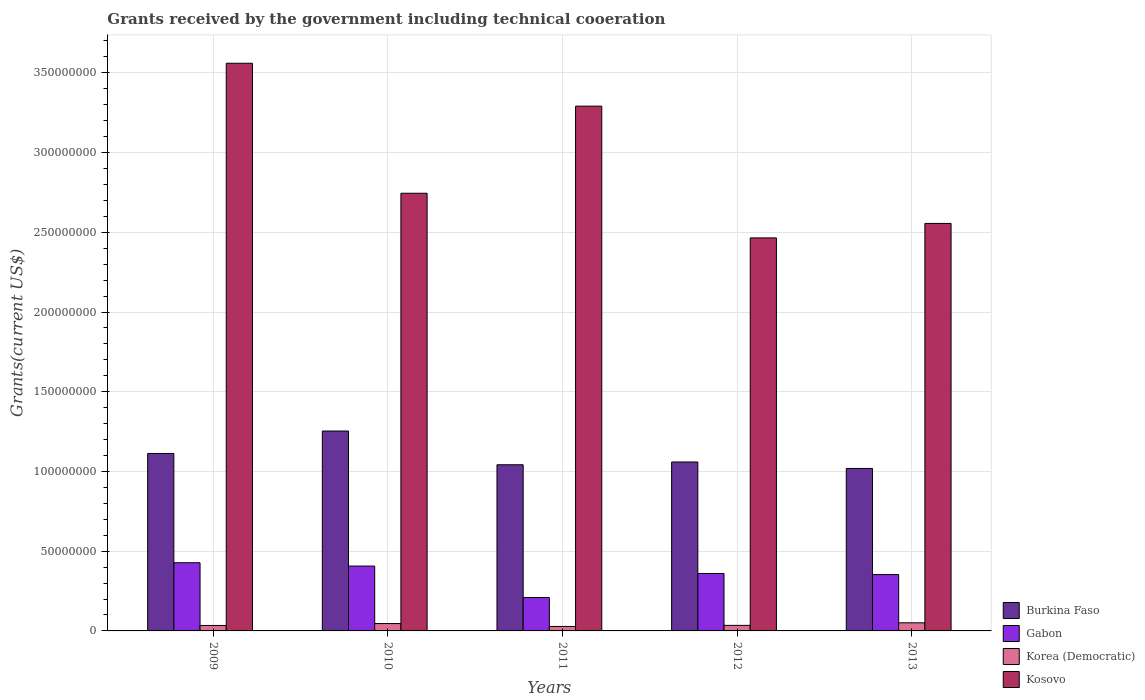How many groups of bars are there?
Provide a short and direct response. 5. How many bars are there on the 4th tick from the right?
Ensure brevity in your answer.  4. In how many cases, is the number of bars for a given year not equal to the number of legend labels?
Keep it short and to the point. 0. What is the total grants received by the government in Korea (Democratic) in 2010?
Your answer should be very brief. 4.62e+06. Across all years, what is the maximum total grants received by the government in Kosovo?
Offer a very short reply. 3.56e+08. Across all years, what is the minimum total grants received by the government in Korea (Democratic)?
Ensure brevity in your answer.  2.80e+06. In which year was the total grants received by the government in Korea (Democratic) maximum?
Offer a terse response. 2013. What is the total total grants received by the government in Kosovo in the graph?
Your answer should be compact. 1.46e+09. What is the difference between the total grants received by the government in Gabon in 2010 and that in 2011?
Offer a terse response. 1.97e+07. What is the difference between the total grants received by the government in Gabon in 2009 and the total grants received by the government in Kosovo in 2013?
Offer a very short reply. -2.13e+08. What is the average total grants received by the government in Kosovo per year?
Provide a short and direct response. 2.92e+08. In the year 2011, what is the difference between the total grants received by the government in Burkina Faso and total grants received by the government in Kosovo?
Offer a terse response. -2.25e+08. What is the ratio of the total grants received by the government in Kosovo in 2009 to that in 2011?
Ensure brevity in your answer.  1.08. Is the total grants received by the government in Kosovo in 2010 less than that in 2011?
Make the answer very short. Yes. Is the difference between the total grants received by the government in Burkina Faso in 2010 and 2012 greater than the difference between the total grants received by the government in Kosovo in 2010 and 2012?
Your answer should be very brief. No. What is the difference between the highest and the second highest total grants received by the government in Korea (Democratic)?
Offer a very short reply. 4.70e+05. What is the difference between the highest and the lowest total grants received by the government in Gabon?
Provide a short and direct response. 2.18e+07. Is the sum of the total grants received by the government in Kosovo in 2010 and 2012 greater than the maximum total grants received by the government in Burkina Faso across all years?
Provide a short and direct response. Yes. What does the 3rd bar from the left in 2010 represents?
Offer a terse response. Korea (Democratic). What does the 4th bar from the right in 2010 represents?
Provide a succinct answer. Burkina Faso. Are all the bars in the graph horizontal?
Offer a terse response. No. How many years are there in the graph?
Provide a succinct answer. 5. Are the values on the major ticks of Y-axis written in scientific E-notation?
Make the answer very short. No. Where does the legend appear in the graph?
Give a very brief answer. Bottom right. How many legend labels are there?
Offer a terse response. 4. How are the legend labels stacked?
Provide a succinct answer. Vertical. What is the title of the graph?
Provide a succinct answer. Grants received by the government including technical cooeration. What is the label or title of the X-axis?
Provide a short and direct response. Years. What is the label or title of the Y-axis?
Offer a very short reply. Grants(current US$). What is the Grants(current US$) of Burkina Faso in 2009?
Keep it short and to the point. 1.11e+08. What is the Grants(current US$) of Gabon in 2009?
Provide a short and direct response. 4.28e+07. What is the Grants(current US$) in Korea (Democratic) in 2009?
Ensure brevity in your answer.  3.42e+06. What is the Grants(current US$) in Kosovo in 2009?
Ensure brevity in your answer.  3.56e+08. What is the Grants(current US$) in Burkina Faso in 2010?
Offer a very short reply. 1.25e+08. What is the Grants(current US$) in Gabon in 2010?
Give a very brief answer. 4.07e+07. What is the Grants(current US$) in Korea (Democratic) in 2010?
Provide a succinct answer. 4.62e+06. What is the Grants(current US$) of Kosovo in 2010?
Keep it short and to the point. 2.74e+08. What is the Grants(current US$) of Burkina Faso in 2011?
Keep it short and to the point. 1.04e+08. What is the Grants(current US$) in Gabon in 2011?
Your answer should be compact. 2.10e+07. What is the Grants(current US$) of Korea (Democratic) in 2011?
Offer a very short reply. 2.80e+06. What is the Grants(current US$) in Kosovo in 2011?
Provide a short and direct response. 3.29e+08. What is the Grants(current US$) of Burkina Faso in 2012?
Provide a short and direct response. 1.06e+08. What is the Grants(current US$) in Gabon in 2012?
Your answer should be compact. 3.60e+07. What is the Grants(current US$) in Korea (Democratic) in 2012?
Offer a terse response. 3.48e+06. What is the Grants(current US$) in Kosovo in 2012?
Offer a terse response. 2.46e+08. What is the Grants(current US$) of Burkina Faso in 2013?
Offer a terse response. 1.02e+08. What is the Grants(current US$) in Gabon in 2013?
Your answer should be very brief. 3.53e+07. What is the Grants(current US$) in Korea (Democratic) in 2013?
Ensure brevity in your answer.  5.09e+06. What is the Grants(current US$) of Kosovo in 2013?
Provide a succinct answer. 2.56e+08. Across all years, what is the maximum Grants(current US$) in Burkina Faso?
Your response must be concise. 1.25e+08. Across all years, what is the maximum Grants(current US$) in Gabon?
Ensure brevity in your answer.  4.28e+07. Across all years, what is the maximum Grants(current US$) in Korea (Democratic)?
Offer a very short reply. 5.09e+06. Across all years, what is the maximum Grants(current US$) in Kosovo?
Your answer should be very brief. 3.56e+08. Across all years, what is the minimum Grants(current US$) in Burkina Faso?
Give a very brief answer. 1.02e+08. Across all years, what is the minimum Grants(current US$) of Gabon?
Your response must be concise. 2.10e+07. Across all years, what is the minimum Grants(current US$) in Korea (Democratic)?
Your answer should be very brief. 2.80e+06. Across all years, what is the minimum Grants(current US$) in Kosovo?
Make the answer very short. 2.46e+08. What is the total Grants(current US$) in Burkina Faso in the graph?
Provide a short and direct response. 5.49e+08. What is the total Grants(current US$) in Gabon in the graph?
Your answer should be very brief. 1.76e+08. What is the total Grants(current US$) of Korea (Democratic) in the graph?
Your answer should be very brief. 1.94e+07. What is the total Grants(current US$) in Kosovo in the graph?
Your answer should be very brief. 1.46e+09. What is the difference between the Grants(current US$) in Burkina Faso in 2009 and that in 2010?
Your answer should be compact. -1.41e+07. What is the difference between the Grants(current US$) of Gabon in 2009 and that in 2010?
Offer a terse response. 2.08e+06. What is the difference between the Grants(current US$) in Korea (Democratic) in 2009 and that in 2010?
Your answer should be compact. -1.20e+06. What is the difference between the Grants(current US$) of Kosovo in 2009 and that in 2010?
Make the answer very short. 8.15e+07. What is the difference between the Grants(current US$) of Burkina Faso in 2009 and that in 2011?
Your answer should be very brief. 7.07e+06. What is the difference between the Grants(current US$) of Gabon in 2009 and that in 2011?
Provide a succinct answer. 2.18e+07. What is the difference between the Grants(current US$) of Korea (Democratic) in 2009 and that in 2011?
Your answer should be very brief. 6.20e+05. What is the difference between the Grants(current US$) of Kosovo in 2009 and that in 2011?
Provide a short and direct response. 2.69e+07. What is the difference between the Grants(current US$) in Burkina Faso in 2009 and that in 2012?
Your answer should be very brief. 5.34e+06. What is the difference between the Grants(current US$) in Gabon in 2009 and that in 2012?
Provide a short and direct response. 6.74e+06. What is the difference between the Grants(current US$) in Korea (Democratic) in 2009 and that in 2012?
Your answer should be very brief. -6.00e+04. What is the difference between the Grants(current US$) in Kosovo in 2009 and that in 2012?
Give a very brief answer. 1.10e+08. What is the difference between the Grants(current US$) in Burkina Faso in 2009 and that in 2013?
Your answer should be very brief. 9.39e+06. What is the difference between the Grants(current US$) in Gabon in 2009 and that in 2013?
Give a very brief answer. 7.42e+06. What is the difference between the Grants(current US$) of Korea (Democratic) in 2009 and that in 2013?
Give a very brief answer. -1.67e+06. What is the difference between the Grants(current US$) of Kosovo in 2009 and that in 2013?
Your response must be concise. 1.00e+08. What is the difference between the Grants(current US$) of Burkina Faso in 2010 and that in 2011?
Keep it short and to the point. 2.12e+07. What is the difference between the Grants(current US$) in Gabon in 2010 and that in 2011?
Your answer should be very brief. 1.97e+07. What is the difference between the Grants(current US$) in Korea (Democratic) in 2010 and that in 2011?
Give a very brief answer. 1.82e+06. What is the difference between the Grants(current US$) in Kosovo in 2010 and that in 2011?
Give a very brief answer. -5.46e+07. What is the difference between the Grants(current US$) in Burkina Faso in 2010 and that in 2012?
Your answer should be compact. 1.94e+07. What is the difference between the Grants(current US$) of Gabon in 2010 and that in 2012?
Keep it short and to the point. 4.66e+06. What is the difference between the Grants(current US$) in Korea (Democratic) in 2010 and that in 2012?
Offer a very short reply. 1.14e+06. What is the difference between the Grants(current US$) in Kosovo in 2010 and that in 2012?
Your response must be concise. 2.80e+07. What is the difference between the Grants(current US$) in Burkina Faso in 2010 and that in 2013?
Provide a succinct answer. 2.35e+07. What is the difference between the Grants(current US$) in Gabon in 2010 and that in 2013?
Offer a very short reply. 5.34e+06. What is the difference between the Grants(current US$) of Korea (Democratic) in 2010 and that in 2013?
Offer a terse response. -4.70e+05. What is the difference between the Grants(current US$) in Kosovo in 2010 and that in 2013?
Keep it short and to the point. 1.89e+07. What is the difference between the Grants(current US$) of Burkina Faso in 2011 and that in 2012?
Offer a terse response. -1.73e+06. What is the difference between the Grants(current US$) in Gabon in 2011 and that in 2012?
Keep it short and to the point. -1.51e+07. What is the difference between the Grants(current US$) of Korea (Democratic) in 2011 and that in 2012?
Ensure brevity in your answer.  -6.80e+05. What is the difference between the Grants(current US$) of Kosovo in 2011 and that in 2012?
Offer a terse response. 8.26e+07. What is the difference between the Grants(current US$) in Burkina Faso in 2011 and that in 2013?
Ensure brevity in your answer.  2.32e+06. What is the difference between the Grants(current US$) in Gabon in 2011 and that in 2013?
Your answer should be compact. -1.44e+07. What is the difference between the Grants(current US$) of Korea (Democratic) in 2011 and that in 2013?
Your answer should be very brief. -2.29e+06. What is the difference between the Grants(current US$) in Kosovo in 2011 and that in 2013?
Give a very brief answer. 7.36e+07. What is the difference between the Grants(current US$) in Burkina Faso in 2012 and that in 2013?
Your response must be concise. 4.05e+06. What is the difference between the Grants(current US$) in Gabon in 2012 and that in 2013?
Keep it short and to the point. 6.80e+05. What is the difference between the Grants(current US$) of Korea (Democratic) in 2012 and that in 2013?
Make the answer very short. -1.61e+06. What is the difference between the Grants(current US$) in Kosovo in 2012 and that in 2013?
Give a very brief answer. -9.07e+06. What is the difference between the Grants(current US$) of Burkina Faso in 2009 and the Grants(current US$) of Gabon in 2010?
Keep it short and to the point. 7.06e+07. What is the difference between the Grants(current US$) in Burkina Faso in 2009 and the Grants(current US$) in Korea (Democratic) in 2010?
Offer a terse response. 1.07e+08. What is the difference between the Grants(current US$) in Burkina Faso in 2009 and the Grants(current US$) in Kosovo in 2010?
Give a very brief answer. -1.63e+08. What is the difference between the Grants(current US$) in Gabon in 2009 and the Grants(current US$) in Korea (Democratic) in 2010?
Provide a short and direct response. 3.81e+07. What is the difference between the Grants(current US$) of Gabon in 2009 and the Grants(current US$) of Kosovo in 2010?
Your answer should be compact. -2.32e+08. What is the difference between the Grants(current US$) in Korea (Democratic) in 2009 and the Grants(current US$) in Kosovo in 2010?
Provide a short and direct response. -2.71e+08. What is the difference between the Grants(current US$) in Burkina Faso in 2009 and the Grants(current US$) in Gabon in 2011?
Keep it short and to the point. 9.03e+07. What is the difference between the Grants(current US$) of Burkina Faso in 2009 and the Grants(current US$) of Korea (Democratic) in 2011?
Ensure brevity in your answer.  1.08e+08. What is the difference between the Grants(current US$) of Burkina Faso in 2009 and the Grants(current US$) of Kosovo in 2011?
Your answer should be very brief. -2.18e+08. What is the difference between the Grants(current US$) in Gabon in 2009 and the Grants(current US$) in Korea (Democratic) in 2011?
Provide a short and direct response. 4.00e+07. What is the difference between the Grants(current US$) of Gabon in 2009 and the Grants(current US$) of Kosovo in 2011?
Keep it short and to the point. -2.86e+08. What is the difference between the Grants(current US$) of Korea (Democratic) in 2009 and the Grants(current US$) of Kosovo in 2011?
Provide a short and direct response. -3.26e+08. What is the difference between the Grants(current US$) in Burkina Faso in 2009 and the Grants(current US$) in Gabon in 2012?
Provide a short and direct response. 7.53e+07. What is the difference between the Grants(current US$) of Burkina Faso in 2009 and the Grants(current US$) of Korea (Democratic) in 2012?
Your response must be concise. 1.08e+08. What is the difference between the Grants(current US$) in Burkina Faso in 2009 and the Grants(current US$) in Kosovo in 2012?
Give a very brief answer. -1.35e+08. What is the difference between the Grants(current US$) in Gabon in 2009 and the Grants(current US$) in Korea (Democratic) in 2012?
Your answer should be very brief. 3.93e+07. What is the difference between the Grants(current US$) in Gabon in 2009 and the Grants(current US$) in Kosovo in 2012?
Your response must be concise. -2.04e+08. What is the difference between the Grants(current US$) of Korea (Democratic) in 2009 and the Grants(current US$) of Kosovo in 2012?
Provide a short and direct response. -2.43e+08. What is the difference between the Grants(current US$) of Burkina Faso in 2009 and the Grants(current US$) of Gabon in 2013?
Ensure brevity in your answer.  7.60e+07. What is the difference between the Grants(current US$) in Burkina Faso in 2009 and the Grants(current US$) in Korea (Democratic) in 2013?
Your answer should be very brief. 1.06e+08. What is the difference between the Grants(current US$) in Burkina Faso in 2009 and the Grants(current US$) in Kosovo in 2013?
Your response must be concise. -1.44e+08. What is the difference between the Grants(current US$) in Gabon in 2009 and the Grants(current US$) in Korea (Democratic) in 2013?
Give a very brief answer. 3.77e+07. What is the difference between the Grants(current US$) in Gabon in 2009 and the Grants(current US$) in Kosovo in 2013?
Your response must be concise. -2.13e+08. What is the difference between the Grants(current US$) of Korea (Democratic) in 2009 and the Grants(current US$) of Kosovo in 2013?
Make the answer very short. -2.52e+08. What is the difference between the Grants(current US$) of Burkina Faso in 2010 and the Grants(current US$) of Gabon in 2011?
Your answer should be compact. 1.04e+08. What is the difference between the Grants(current US$) of Burkina Faso in 2010 and the Grants(current US$) of Korea (Democratic) in 2011?
Make the answer very short. 1.23e+08. What is the difference between the Grants(current US$) in Burkina Faso in 2010 and the Grants(current US$) in Kosovo in 2011?
Make the answer very short. -2.04e+08. What is the difference between the Grants(current US$) of Gabon in 2010 and the Grants(current US$) of Korea (Democratic) in 2011?
Ensure brevity in your answer.  3.79e+07. What is the difference between the Grants(current US$) in Gabon in 2010 and the Grants(current US$) in Kosovo in 2011?
Your answer should be compact. -2.88e+08. What is the difference between the Grants(current US$) in Korea (Democratic) in 2010 and the Grants(current US$) in Kosovo in 2011?
Provide a short and direct response. -3.25e+08. What is the difference between the Grants(current US$) in Burkina Faso in 2010 and the Grants(current US$) in Gabon in 2012?
Provide a short and direct response. 8.94e+07. What is the difference between the Grants(current US$) of Burkina Faso in 2010 and the Grants(current US$) of Korea (Democratic) in 2012?
Offer a terse response. 1.22e+08. What is the difference between the Grants(current US$) of Burkina Faso in 2010 and the Grants(current US$) of Kosovo in 2012?
Provide a succinct answer. -1.21e+08. What is the difference between the Grants(current US$) of Gabon in 2010 and the Grants(current US$) of Korea (Democratic) in 2012?
Give a very brief answer. 3.72e+07. What is the difference between the Grants(current US$) of Gabon in 2010 and the Grants(current US$) of Kosovo in 2012?
Your answer should be compact. -2.06e+08. What is the difference between the Grants(current US$) in Korea (Democratic) in 2010 and the Grants(current US$) in Kosovo in 2012?
Give a very brief answer. -2.42e+08. What is the difference between the Grants(current US$) in Burkina Faso in 2010 and the Grants(current US$) in Gabon in 2013?
Ensure brevity in your answer.  9.00e+07. What is the difference between the Grants(current US$) of Burkina Faso in 2010 and the Grants(current US$) of Korea (Democratic) in 2013?
Provide a short and direct response. 1.20e+08. What is the difference between the Grants(current US$) of Burkina Faso in 2010 and the Grants(current US$) of Kosovo in 2013?
Ensure brevity in your answer.  -1.30e+08. What is the difference between the Grants(current US$) in Gabon in 2010 and the Grants(current US$) in Korea (Democratic) in 2013?
Your answer should be compact. 3.56e+07. What is the difference between the Grants(current US$) of Gabon in 2010 and the Grants(current US$) of Kosovo in 2013?
Keep it short and to the point. -2.15e+08. What is the difference between the Grants(current US$) in Korea (Democratic) in 2010 and the Grants(current US$) in Kosovo in 2013?
Offer a very short reply. -2.51e+08. What is the difference between the Grants(current US$) of Burkina Faso in 2011 and the Grants(current US$) of Gabon in 2012?
Provide a short and direct response. 6.82e+07. What is the difference between the Grants(current US$) in Burkina Faso in 2011 and the Grants(current US$) in Korea (Democratic) in 2012?
Your answer should be compact. 1.01e+08. What is the difference between the Grants(current US$) of Burkina Faso in 2011 and the Grants(current US$) of Kosovo in 2012?
Offer a very short reply. -1.42e+08. What is the difference between the Grants(current US$) in Gabon in 2011 and the Grants(current US$) in Korea (Democratic) in 2012?
Make the answer very short. 1.75e+07. What is the difference between the Grants(current US$) of Gabon in 2011 and the Grants(current US$) of Kosovo in 2012?
Keep it short and to the point. -2.26e+08. What is the difference between the Grants(current US$) of Korea (Democratic) in 2011 and the Grants(current US$) of Kosovo in 2012?
Offer a very short reply. -2.44e+08. What is the difference between the Grants(current US$) in Burkina Faso in 2011 and the Grants(current US$) in Gabon in 2013?
Give a very brief answer. 6.89e+07. What is the difference between the Grants(current US$) in Burkina Faso in 2011 and the Grants(current US$) in Korea (Democratic) in 2013?
Provide a succinct answer. 9.91e+07. What is the difference between the Grants(current US$) in Burkina Faso in 2011 and the Grants(current US$) in Kosovo in 2013?
Make the answer very short. -1.51e+08. What is the difference between the Grants(current US$) of Gabon in 2011 and the Grants(current US$) of Korea (Democratic) in 2013?
Your answer should be very brief. 1.59e+07. What is the difference between the Grants(current US$) of Gabon in 2011 and the Grants(current US$) of Kosovo in 2013?
Your response must be concise. -2.35e+08. What is the difference between the Grants(current US$) in Korea (Democratic) in 2011 and the Grants(current US$) in Kosovo in 2013?
Provide a succinct answer. -2.53e+08. What is the difference between the Grants(current US$) in Burkina Faso in 2012 and the Grants(current US$) in Gabon in 2013?
Give a very brief answer. 7.06e+07. What is the difference between the Grants(current US$) in Burkina Faso in 2012 and the Grants(current US$) in Korea (Democratic) in 2013?
Provide a short and direct response. 1.01e+08. What is the difference between the Grants(current US$) of Burkina Faso in 2012 and the Grants(current US$) of Kosovo in 2013?
Offer a terse response. -1.50e+08. What is the difference between the Grants(current US$) in Gabon in 2012 and the Grants(current US$) in Korea (Democratic) in 2013?
Ensure brevity in your answer.  3.09e+07. What is the difference between the Grants(current US$) of Gabon in 2012 and the Grants(current US$) of Kosovo in 2013?
Your response must be concise. -2.20e+08. What is the difference between the Grants(current US$) of Korea (Democratic) in 2012 and the Grants(current US$) of Kosovo in 2013?
Make the answer very short. -2.52e+08. What is the average Grants(current US$) in Burkina Faso per year?
Your answer should be compact. 1.10e+08. What is the average Grants(current US$) in Gabon per year?
Provide a short and direct response. 3.52e+07. What is the average Grants(current US$) in Korea (Democratic) per year?
Provide a succinct answer. 3.88e+06. What is the average Grants(current US$) of Kosovo per year?
Your answer should be compact. 2.92e+08. In the year 2009, what is the difference between the Grants(current US$) of Burkina Faso and Grants(current US$) of Gabon?
Provide a short and direct response. 6.85e+07. In the year 2009, what is the difference between the Grants(current US$) of Burkina Faso and Grants(current US$) of Korea (Democratic)?
Provide a succinct answer. 1.08e+08. In the year 2009, what is the difference between the Grants(current US$) of Burkina Faso and Grants(current US$) of Kosovo?
Your response must be concise. -2.45e+08. In the year 2009, what is the difference between the Grants(current US$) in Gabon and Grants(current US$) in Korea (Democratic)?
Keep it short and to the point. 3.93e+07. In the year 2009, what is the difference between the Grants(current US$) in Gabon and Grants(current US$) in Kosovo?
Make the answer very short. -3.13e+08. In the year 2009, what is the difference between the Grants(current US$) of Korea (Democratic) and Grants(current US$) of Kosovo?
Keep it short and to the point. -3.53e+08. In the year 2010, what is the difference between the Grants(current US$) of Burkina Faso and Grants(current US$) of Gabon?
Your answer should be very brief. 8.47e+07. In the year 2010, what is the difference between the Grants(current US$) of Burkina Faso and Grants(current US$) of Korea (Democratic)?
Provide a short and direct response. 1.21e+08. In the year 2010, what is the difference between the Grants(current US$) of Burkina Faso and Grants(current US$) of Kosovo?
Make the answer very short. -1.49e+08. In the year 2010, what is the difference between the Grants(current US$) of Gabon and Grants(current US$) of Korea (Democratic)?
Keep it short and to the point. 3.61e+07. In the year 2010, what is the difference between the Grants(current US$) in Gabon and Grants(current US$) in Kosovo?
Give a very brief answer. -2.34e+08. In the year 2010, what is the difference between the Grants(current US$) in Korea (Democratic) and Grants(current US$) in Kosovo?
Your response must be concise. -2.70e+08. In the year 2011, what is the difference between the Grants(current US$) in Burkina Faso and Grants(current US$) in Gabon?
Keep it short and to the point. 8.33e+07. In the year 2011, what is the difference between the Grants(current US$) in Burkina Faso and Grants(current US$) in Korea (Democratic)?
Give a very brief answer. 1.01e+08. In the year 2011, what is the difference between the Grants(current US$) of Burkina Faso and Grants(current US$) of Kosovo?
Provide a short and direct response. -2.25e+08. In the year 2011, what is the difference between the Grants(current US$) of Gabon and Grants(current US$) of Korea (Democratic)?
Keep it short and to the point. 1.82e+07. In the year 2011, what is the difference between the Grants(current US$) of Gabon and Grants(current US$) of Kosovo?
Your answer should be compact. -3.08e+08. In the year 2011, what is the difference between the Grants(current US$) in Korea (Democratic) and Grants(current US$) in Kosovo?
Provide a short and direct response. -3.26e+08. In the year 2012, what is the difference between the Grants(current US$) in Burkina Faso and Grants(current US$) in Gabon?
Your answer should be compact. 6.99e+07. In the year 2012, what is the difference between the Grants(current US$) of Burkina Faso and Grants(current US$) of Korea (Democratic)?
Offer a very short reply. 1.02e+08. In the year 2012, what is the difference between the Grants(current US$) in Burkina Faso and Grants(current US$) in Kosovo?
Your answer should be very brief. -1.41e+08. In the year 2012, what is the difference between the Grants(current US$) in Gabon and Grants(current US$) in Korea (Democratic)?
Make the answer very short. 3.25e+07. In the year 2012, what is the difference between the Grants(current US$) of Gabon and Grants(current US$) of Kosovo?
Provide a short and direct response. -2.10e+08. In the year 2012, what is the difference between the Grants(current US$) of Korea (Democratic) and Grants(current US$) of Kosovo?
Ensure brevity in your answer.  -2.43e+08. In the year 2013, what is the difference between the Grants(current US$) of Burkina Faso and Grants(current US$) of Gabon?
Provide a short and direct response. 6.66e+07. In the year 2013, what is the difference between the Grants(current US$) of Burkina Faso and Grants(current US$) of Korea (Democratic)?
Give a very brief answer. 9.68e+07. In the year 2013, what is the difference between the Grants(current US$) of Burkina Faso and Grants(current US$) of Kosovo?
Offer a very short reply. -1.54e+08. In the year 2013, what is the difference between the Grants(current US$) in Gabon and Grants(current US$) in Korea (Democratic)?
Make the answer very short. 3.02e+07. In the year 2013, what is the difference between the Grants(current US$) in Gabon and Grants(current US$) in Kosovo?
Keep it short and to the point. -2.20e+08. In the year 2013, what is the difference between the Grants(current US$) in Korea (Democratic) and Grants(current US$) in Kosovo?
Your answer should be very brief. -2.50e+08. What is the ratio of the Grants(current US$) of Burkina Faso in 2009 to that in 2010?
Give a very brief answer. 0.89. What is the ratio of the Grants(current US$) of Gabon in 2009 to that in 2010?
Provide a succinct answer. 1.05. What is the ratio of the Grants(current US$) in Korea (Democratic) in 2009 to that in 2010?
Offer a very short reply. 0.74. What is the ratio of the Grants(current US$) of Kosovo in 2009 to that in 2010?
Your answer should be very brief. 1.3. What is the ratio of the Grants(current US$) in Burkina Faso in 2009 to that in 2011?
Make the answer very short. 1.07. What is the ratio of the Grants(current US$) in Gabon in 2009 to that in 2011?
Provide a succinct answer. 2.04. What is the ratio of the Grants(current US$) of Korea (Democratic) in 2009 to that in 2011?
Provide a short and direct response. 1.22. What is the ratio of the Grants(current US$) in Kosovo in 2009 to that in 2011?
Keep it short and to the point. 1.08. What is the ratio of the Grants(current US$) of Burkina Faso in 2009 to that in 2012?
Your answer should be very brief. 1.05. What is the ratio of the Grants(current US$) of Gabon in 2009 to that in 2012?
Your answer should be compact. 1.19. What is the ratio of the Grants(current US$) in Korea (Democratic) in 2009 to that in 2012?
Provide a succinct answer. 0.98. What is the ratio of the Grants(current US$) of Kosovo in 2009 to that in 2012?
Keep it short and to the point. 1.44. What is the ratio of the Grants(current US$) of Burkina Faso in 2009 to that in 2013?
Give a very brief answer. 1.09. What is the ratio of the Grants(current US$) of Gabon in 2009 to that in 2013?
Offer a terse response. 1.21. What is the ratio of the Grants(current US$) of Korea (Democratic) in 2009 to that in 2013?
Give a very brief answer. 0.67. What is the ratio of the Grants(current US$) in Kosovo in 2009 to that in 2013?
Keep it short and to the point. 1.39. What is the ratio of the Grants(current US$) of Burkina Faso in 2010 to that in 2011?
Your answer should be compact. 1.2. What is the ratio of the Grants(current US$) in Gabon in 2010 to that in 2011?
Offer a terse response. 1.94. What is the ratio of the Grants(current US$) in Korea (Democratic) in 2010 to that in 2011?
Provide a short and direct response. 1.65. What is the ratio of the Grants(current US$) in Kosovo in 2010 to that in 2011?
Provide a succinct answer. 0.83. What is the ratio of the Grants(current US$) of Burkina Faso in 2010 to that in 2012?
Your answer should be very brief. 1.18. What is the ratio of the Grants(current US$) of Gabon in 2010 to that in 2012?
Make the answer very short. 1.13. What is the ratio of the Grants(current US$) in Korea (Democratic) in 2010 to that in 2012?
Offer a very short reply. 1.33. What is the ratio of the Grants(current US$) in Kosovo in 2010 to that in 2012?
Offer a very short reply. 1.11. What is the ratio of the Grants(current US$) of Burkina Faso in 2010 to that in 2013?
Ensure brevity in your answer.  1.23. What is the ratio of the Grants(current US$) in Gabon in 2010 to that in 2013?
Keep it short and to the point. 1.15. What is the ratio of the Grants(current US$) of Korea (Democratic) in 2010 to that in 2013?
Your response must be concise. 0.91. What is the ratio of the Grants(current US$) of Kosovo in 2010 to that in 2013?
Ensure brevity in your answer.  1.07. What is the ratio of the Grants(current US$) of Burkina Faso in 2011 to that in 2012?
Your answer should be compact. 0.98. What is the ratio of the Grants(current US$) of Gabon in 2011 to that in 2012?
Your answer should be compact. 0.58. What is the ratio of the Grants(current US$) in Korea (Democratic) in 2011 to that in 2012?
Ensure brevity in your answer.  0.8. What is the ratio of the Grants(current US$) of Kosovo in 2011 to that in 2012?
Make the answer very short. 1.34. What is the ratio of the Grants(current US$) of Burkina Faso in 2011 to that in 2013?
Your answer should be compact. 1.02. What is the ratio of the Grants(current US$) in Gabon in 2011 to that in 2013?
Provide a succinct answer. 0.59. What is the ratio of the Grants(current US$) of Korea (Democratic) in 2011 to that in 2013?
Make the answer very short. 0.55. What is the ratio of the Grants(current US$) of Kosovo in 2011 to that in 2013?
Make the answer very short. 1.29. What is the ratio of the Grants(current US$) in Burkina Faso in 2012 to that in 2013?
Your answer should be very brief. 1.04. What is the ratio of the Grants(current US$) of Gabon in 2012 to that in 2013?
Your answer should be very brief. 1.02. What is the ratio of the Grants(current US$) in Korea (Democratic) in 2012 to that in 2013?
Offer a very short reply. 0.68. What is the ratio of the Grants(current US$) in Kosovo in 2012 to that in 2013?
Your response must be concise. 0.96. What is the difference between the highest and the second highest Grants(current US$) of Burkina Faso?
Provide a short and direct response. 1.41e+07. What is the difference between the highest and the second highest Grants(current US$) in Gabon?
Give a very brief answer. 2.08e+06. What is the difference between the highest and the second highest Grants(current US$) of Korea (Democratic)?
Give a very brief answer. 4.70e+05. What is the difference between the highest and the second highest Grants(current US$) of Kosovo?
Provide a succinct answer. 2.69e+07. What is the difference between the highest and the lowest Grants(current US$) of Burkina Faso?
Your answer should be very brief. 2.35e+07. What is the difference between the highest and the lowest Grants(current US$) of Gabon?
Keep it short and to the point. 2.18e+07. What is the difference between the highest and the lowest Grants(current US$) of Korea (Democratic)?
Provide a succinct answer. 2.29e+06. What is the difference between the highest and the lowest Grants(current US$) of Kosovo?
Give a very brief answer. 1.10e+08. 